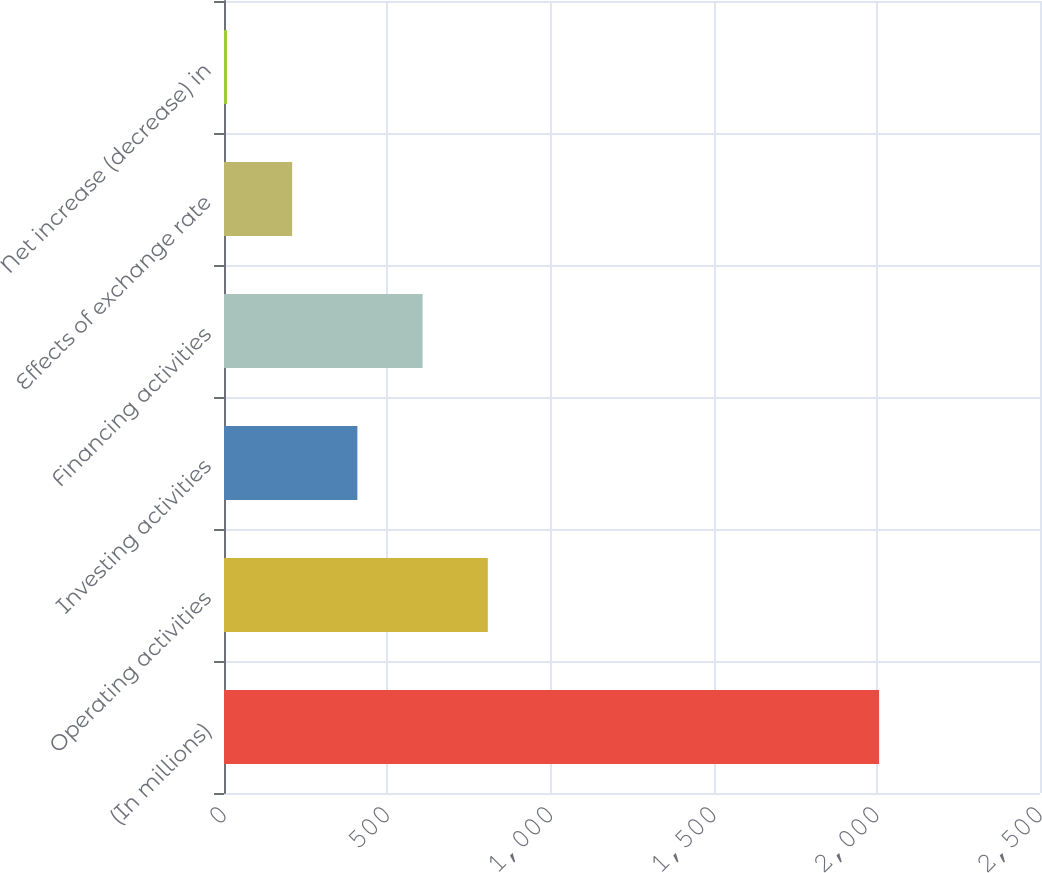Convert chart. <chart><loc_0><loc_0><loc_500><loc_500><bar_chart><fcel>(In millions)<fcel>Operating activities<fcel>Investing activities<fcel>Financing activities<fcel>Effects of exchange rate<fcel>Net increase (decrease) in<nl><fcel>2007<fcel>808.2<fcel>408.6<fcel>608.4<fcel>208.8<fcel>9<nl></chart> 